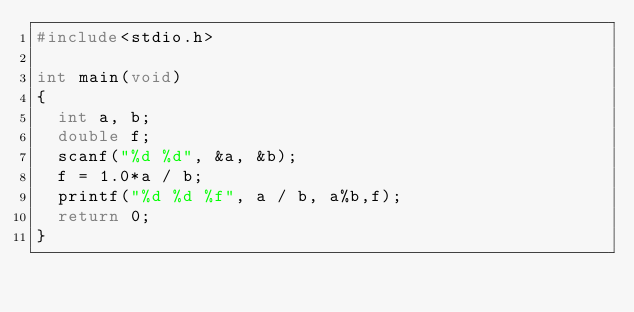<code> <loc_0><loc_0><loc_500><loc_500><_C_>#include<stdio.h>

int main(void)
{
	int a, b;
	double f;
	scanf("%d %d", &a, &b);
	f = 1.0*a / b;
	printf("%d %d %f", a / b, a%b,f);
	return 0;
}
</code> 